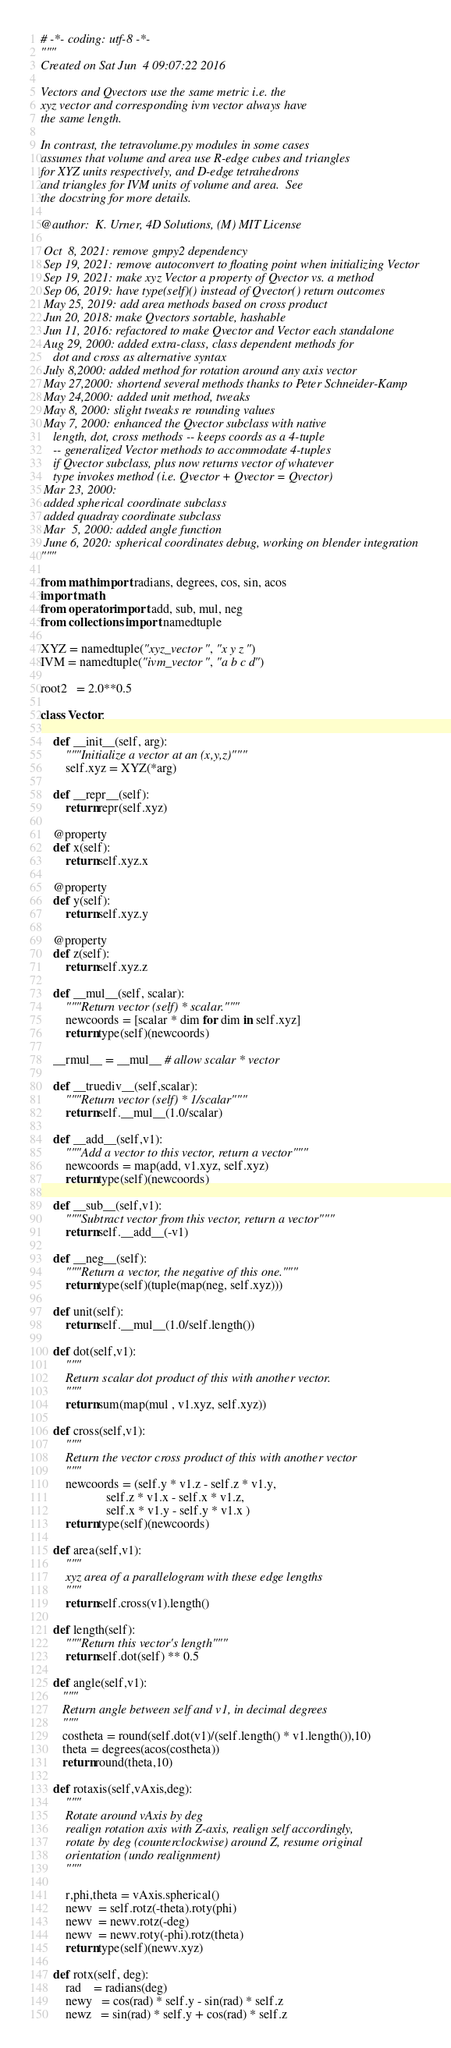<code> <loc_0><loc_0><loc_500><loc_500><_Python_># -*- coding: utf-8 -*-
"""
Created on Sat Jun  4 09:07:22 2016

Vectors and Qvectors use the same metric i.e. the 
xyz vector and corresponding ivm vector always have 
the same length.

In contrast, the tetravolume.py modules in some cases 
assumes that volume and area use R-edge cubes and triangles
for XYZ units respectively, and D-edge tetrahedrons 
and triangles for IVM units of volume and area.  See
the docstring for more details.

@author:  K. Urner, 4D Solutions, (M) MIT License

 Oct  8, 2021: remove gmpy2 dependency
 Sep 19, 2021: remove autoconvert to floating point when initializing Vector
 Sep 19, 2021: make xyz Vector a property of Qvector vs. a method
 Sep 06, 2019: have type(self)() instead of Qvector() return outcomes
 May 25, 2019: add area methods based on cross product
 Jun 20, 2018: make Qvectors sortable, hashable
 Jun 11, 2016: refactored to make Qvector and Vector each standalone
 Aug 29, 2000: added extra-class, class dependent methods for
    dot and cross as alternative syntax
 July 8,2000: added method for rotation around any axis vector
 May 27,2000: shortend several methods thanks to Peter Schneider-Kamp
 May 24,2000: added unit method, tweaks
 May 8, 2000: slight tweaks re rounding values
 May 7, 2000: enhanced the Qvector subclass with native
    length, dot, cross methods -- keeps coords as a 4-tuple
    -- generalized Vector methods to accommodate 4-tuples
    if Qvector subclass, plus now returns vector of whatever
    type invokes method (i.e. Qvector + Qvector = Qvector)
 Mar 23, 2000:
 added spherical coordinate subclass
 added quadray coordinate subclass
 Mar  5, 2000: added angle function
 June 6, 2020: spherical coordinates debug, working on blender integration
"""

from math import radians, degrees, cos, sin, acos
import math
from operator import add, sub, mul, neg
from collections import namedtuple

XYZ = namedtuple("xyz_vector", "x y z")
IVM = namedtuple("ivm_vector", "a b c d")

root2   = 2.0**0.5

class Vector:

    def __init__(self, arg):
        """Initialize a vector at an (x,y,z)"""
        self.xyz = XYZ(*arg)

    def __repr__(self):
        return repr(self.xyz)
    
    @property
    def x(self):
        return self.xyz.x

    @property
    def y(self):
        return self.xyz.y

    @property
    def z(self):
        return self.xyz.z
        
    def __mul__(self, scalar):
        """Return vector (self) * scalar."""
        newcoords = [scalar * dim for dim in self.xyz]
        return type(self)(newcoords)

    __rmul__ = __mul__ # allow scalar * vector

    def __truediv__(self,scalar):
        """Return vector (self) * 1/scalar"""        
        return self.__mul__(1.0/scalar)
    
    def __add__(self,v1):
        """Add a vector to this vector, return a vector""" 
        newcoords = map(add, v1.xyz, self.xyz)
        return type(self)(newcoords)
        
    def __sub__(self,v1):
        """Subtract vector from this vector, return a vector"""
        return self.__add__(-v1)
    
    def __neg__(self):      
        """Return a vector, the negative of this one."""
        return type(self)(tuple(map(neg, self.xyz)))

    def unit(self):
        return self.__mul__(1.0/self.length())

    def dot(self,v1):
        """
        Return scalar dot product of this with another vector.
        """
        return sum(map(mul , v1.xyz, self.xyz))

    def cross(self,v1):
        """
        Return the vector cross product of this with another vector
        """
        newcoords = (self.y * v1.z - self.z * v1.y, 
                     self.z * v1.x - self.x * v1.z,
                     self.x * v1.y - self.y * v1.x )
        return type(self)(newcoords)
    
    def area(self,v1):
        """
        xyz area of a parallelogram with these edge lengths
        """
        return self.cross(v1).length()
    
    def length(self):
        """Return this vector's length"""
        return self.dot(self) ** 0.5

    def angle(self,v1):
       """
       Return angle between self and v1, in decimal degrees
       """
       costheta = round(self.dot(v1)/(self.length() * v1.length()),10)
       theta = degrees(acos(costheta))
       return round(theta,10)

    def rotaxis(self,vAxis,deg):
        """
        Rotate around vAxis by deg
        realign rotation axis with Z-axis, realign self accordingly,
        rotate by deg (counterclockwise) around Z, resume original
        orientation (undo realignment)
        """
        
        r,phi,theta = vAxis.spherical()
        newv  = self.rotz(-theta).roty(phi)
        newv  = newv.rotz(-deg)
        newv  = newv.roty(-phi).rotz(theta)
        return type(self)(newv.xyz)        

    def rotx(self, deg):
        rad    = radians(deg)
        newy   = cos(rad) * self.y - sin(rad) * self.z
        newz   = sin(rad) * self.y + cos(rad) * self.z</code> 